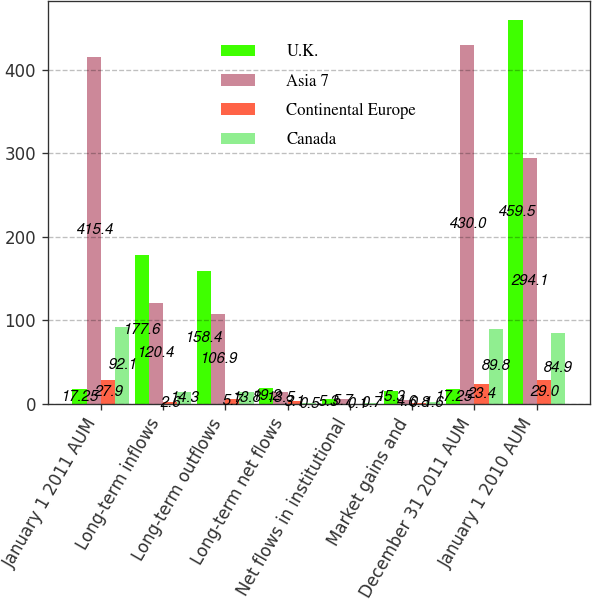Convert chart to OTSL. <chart><loc_0><loc_0><loc_500><loc_500><stacked_bar_chart><ecel><fcel>January 1 2011 AUM<fcel>Long-term inflows<fcel>Long-term outflows<fcel>Long-term net flows<fcel>Net flows in institutional<fcel>Market gains and<fcel>December 31 2011 AUM<fcel>January 1 2010 AUM<nl><fcel>U.K.<fcel>17.25<fcel>177.6<fcel>158.4<fcel>19.2<fcel>5.3<fcel>15.3<fcel>17.25<fcel>459.5<nl><fcel>Asia 7<fcel>415.4<fcel>120.4<fcel>106.9<fcel>13.5<fcel>5.7<fcel>4.6<fcel>430<fcel>294.1<nl><fcel>Continental Europe<fcel>27.9<fcel>2.6<fcel>5.7<fcel>3.1<fcel>0.1<fcel>0.8<fcel>23.4<fcel>29<nl><fcel>Canada<fcel>92.1<fcel>14.3<fcel>13.8<fcel>0.5<fcel>0.7<fcel>1.6<fcel>89.8<fcel>84.9<nl></chart> 